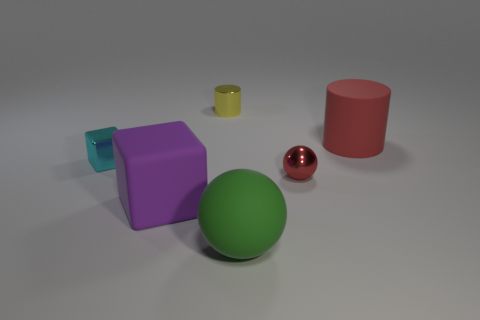Add 4 big matte blocks. How many objects exist? 10 Subtract all cylinders. How many objects are left? 4 Subtract 0 cyan balls. How many objects are left? 6 Subtract all matte cylinders. Subtract all big things. How many objects are left? 2 Add 6 large matte balls. How many large matte balls are left? 7 Add 4 big brown shiny objects. How many big brown shiny objects exist? 4 